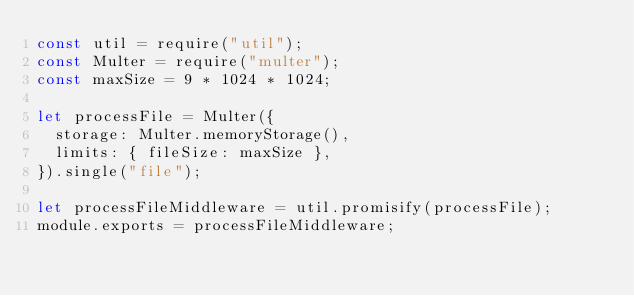Convert code to text. <code><loc_0><loc_0><loc_500><loc_500><_JavaScript_>const util = require("util");
const Multer = require("multer");
const maxSize = 9 * 1024 * 1024;

let processFile = Multer({
  storage: Multer.memoryStorage(),
  limits: { fileSize: maxSize },
}).single("file");

let processFileMiddleware = util.promisify(processFile);
module.exports = processFileMiddleware;</code> 